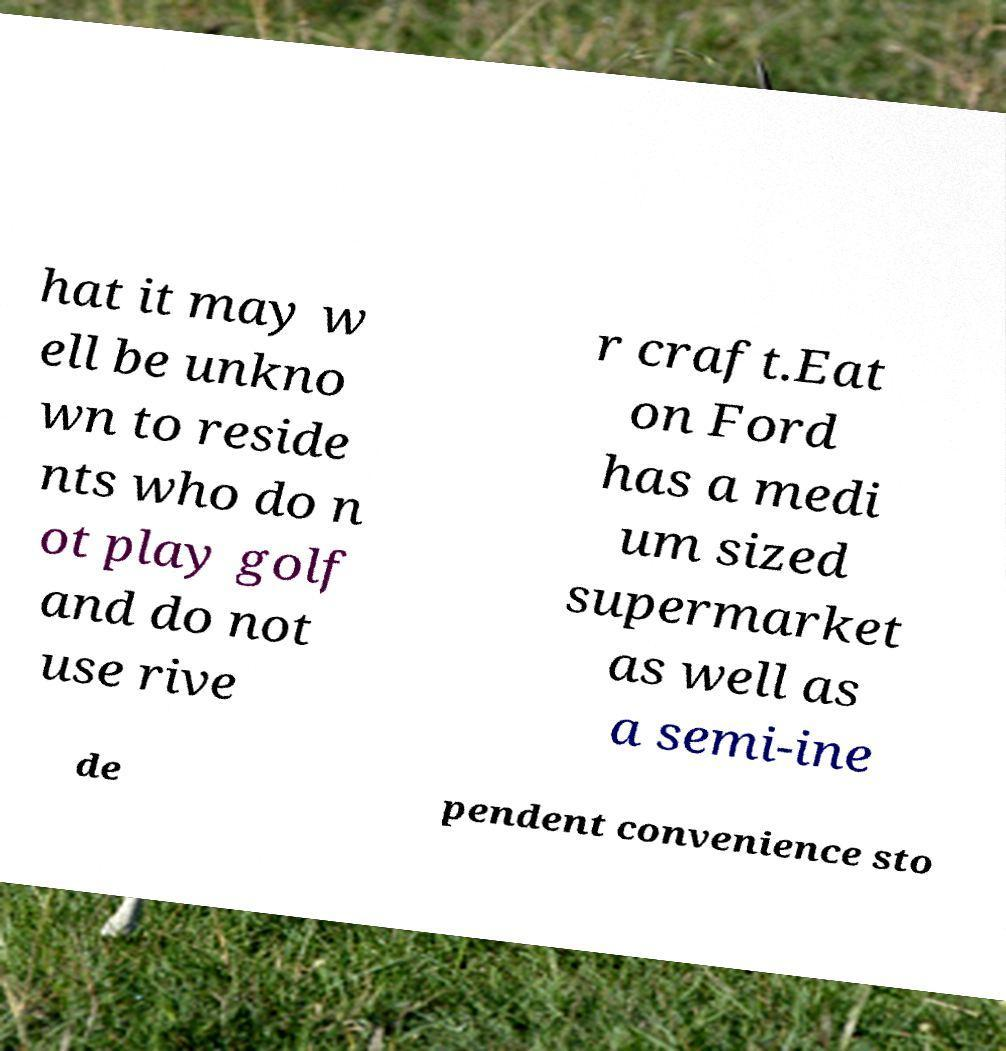There's text embedded in this image that I need extracted. Can you transcribe it verbatim? hat it may w ell be unkno wn to reside nts who do n ot play golf and do not use rive r craft.Eat on Ford has a medi um sized supermarket as well as a semi-ine de pendent convenience sto 